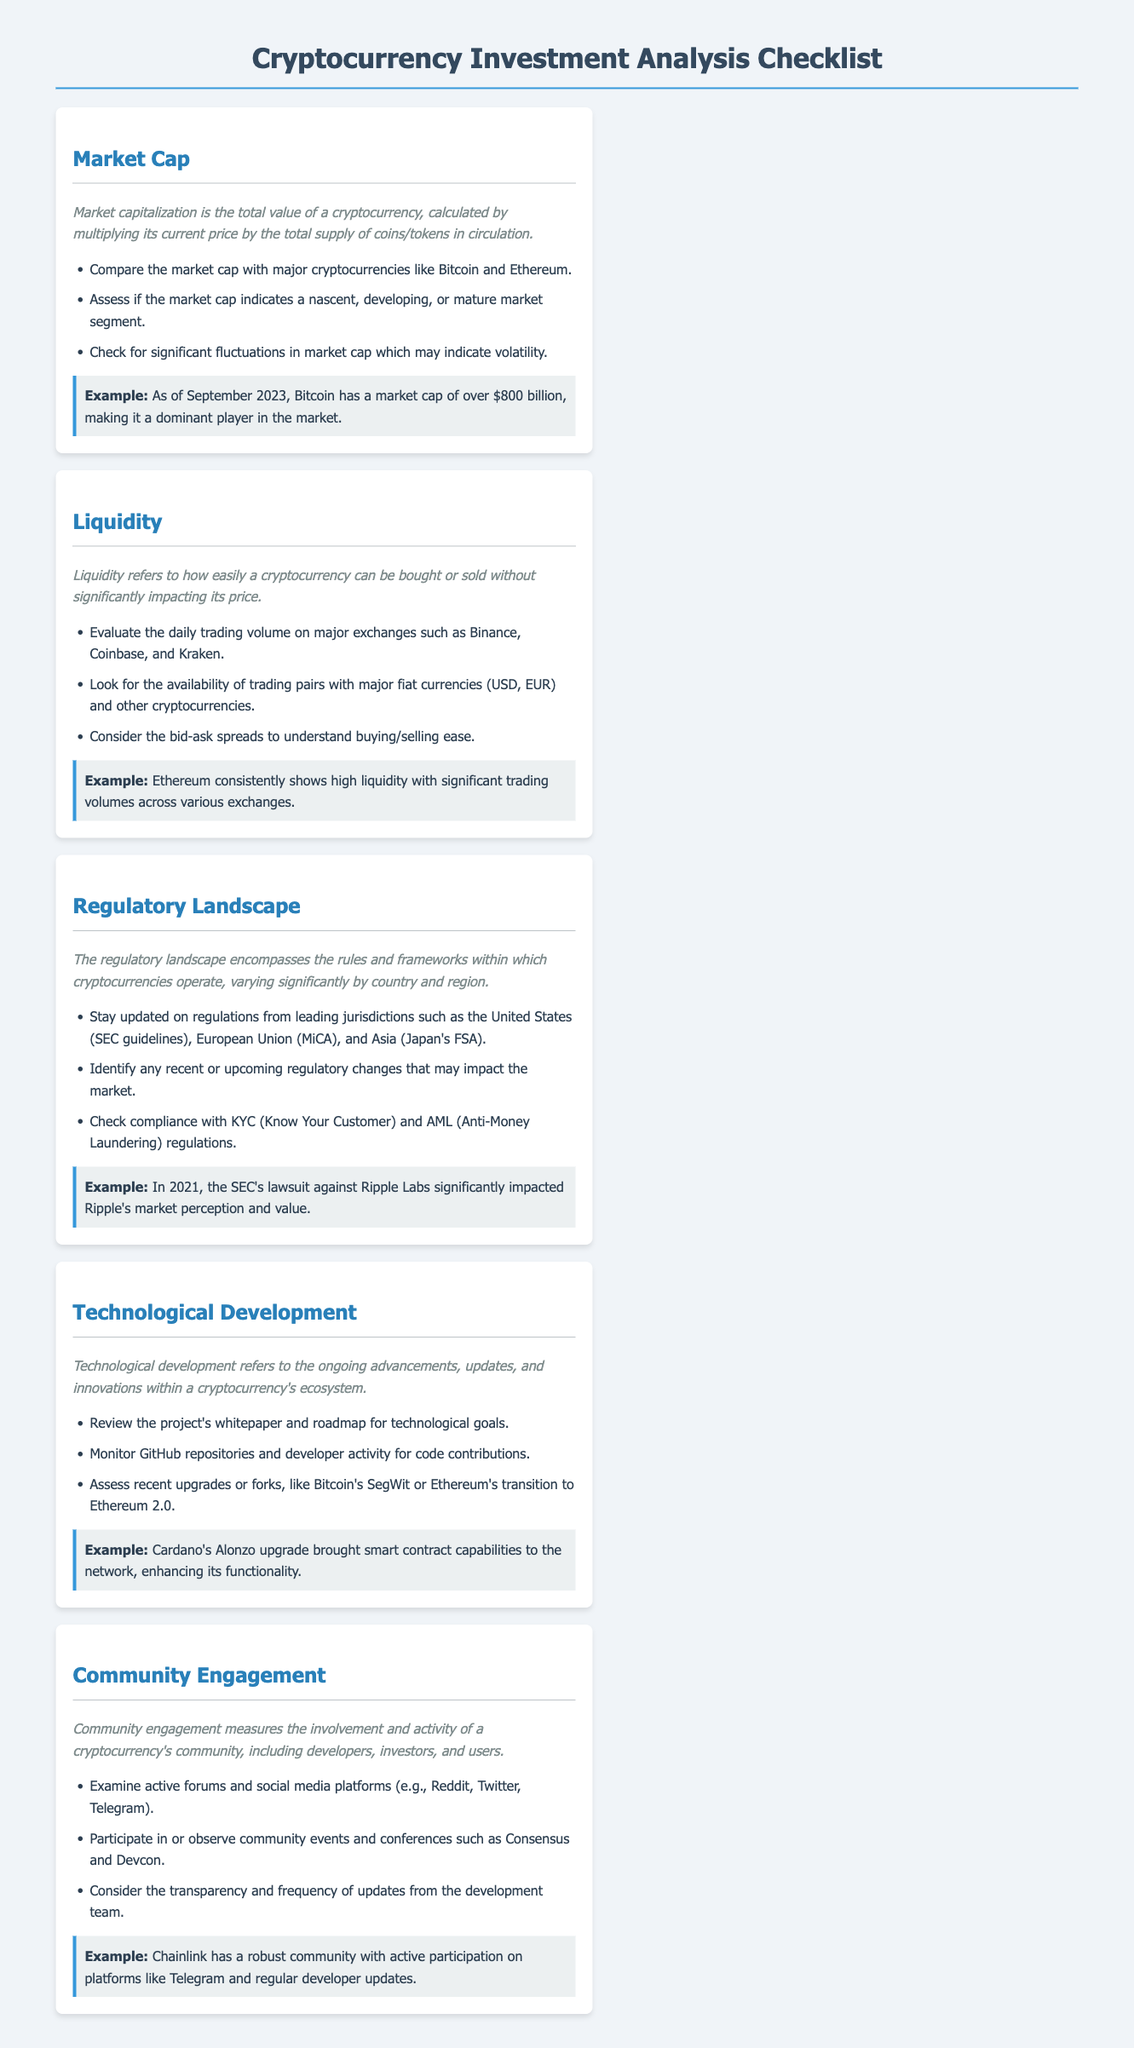What is the definition of market cap? Market capitalization is defined as the total value of a cryptocurrency, calculated by multiplying its current price by the total supply of coins/tokens in circulation.
Answer: Total value of a cryptocurrency What is a significant trading volume exchange mentioned for liquidity? The document suggests evaluating daily trading volumes on major exchanges such as Binance, Coinbase, and Kraken for liquidity analysis.
Answer: Binance What regulatory framework is mentioned for the European Union? The document highlights the MiCA as a regulatory framework within the European Union for cryptocurrency operations.
Answer: MiCA What upgrade enhanced Cardano’s functionality? The Alonzo upgrade is noted as a significant advancement that brought smart contract capabilities to the Cardano network.
Answer: Alonzo upgrade Which community engagement platform is specified for Chainlink? The document refers to Telegram as a significant platform for active community participation regarding Chainlink.
Answer: Telegram What key aspect does liquidity refer to? Liquidity refers to how easily a cryptocurrency can be bought or sold without significantly impacting its price.
Answer: Ease of buying/selling What example is provided for Bitcoin's market cap as of September 2023? The document states that Bitcoin has a market cap of over $800 billion, indicating its dominant player status in the market.
Answer: Over $800 billion Which aspect involves reviewing project whitepapers and roadmaps? Technological development focuses on reviewing the project's whitepaper and roadmap for its technological goals.
Answer: Technological goals What recent impact was cited regarding the SEC and Ripple Labs? The document notes that the SEC's lawsuit against Ripple Labs significantly impacted Ripple's market perception and value.
Answer: Market perception and value 